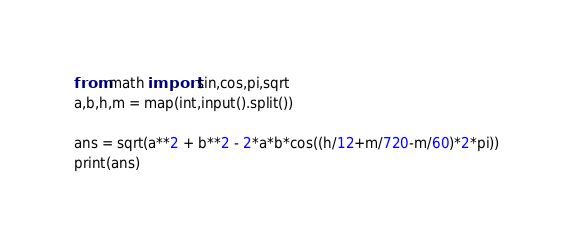Convert code to text. <code><loc_0><loc_0><loc_500><loc_500><_Python_>from math import sin,cos,pi,sqrt
a,b,h,m = map(int,input().split())

ans = sqrt(a**2 + b**2 - 2*a*b*cos((h/12+m/720-m/60)*2*pi))
print(ans)
</code> 